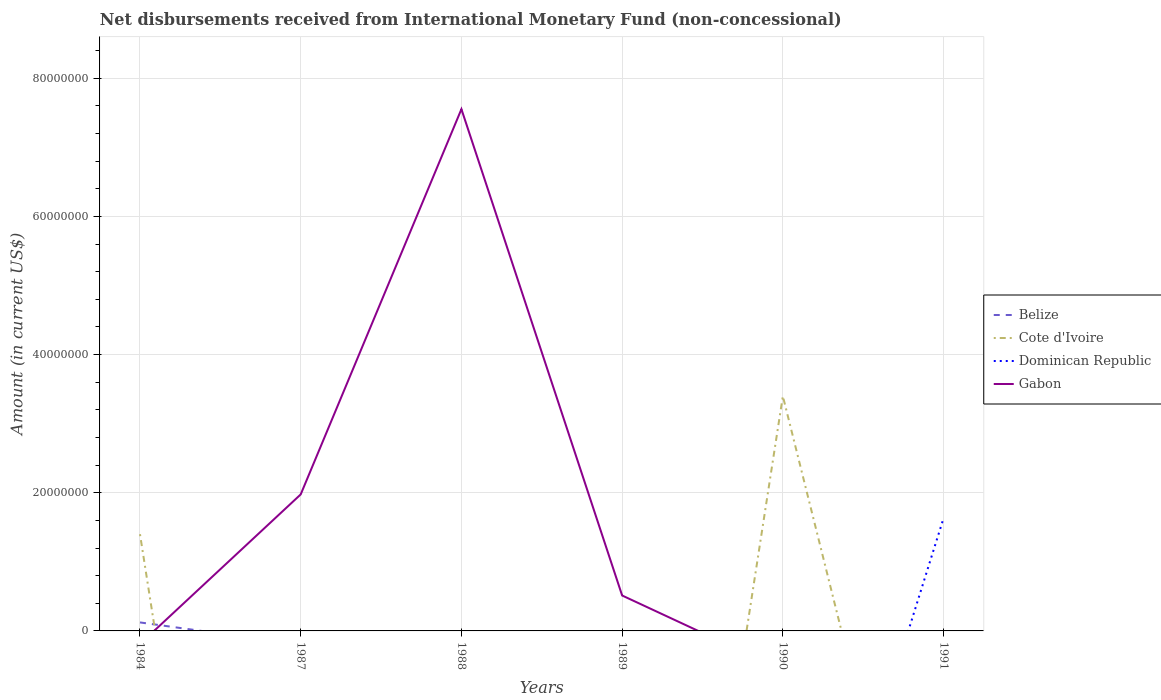Across all years, what is the maximum amount of disbursements received from International Monetary Fund in Cote d'Ivoire?
Your answer should be very brief. 0. What is the total amount of disbursements received from International Monetary Fund in Gabon in the graph?
Make the answer very short. 7.04e+07. What is the difference between the highest and the second highest amount of disbursements received from International Monetary Fund in Belize?
Your answer should be compact. 1.23e+06. How many lines are there?
Your answer should be compact. 4. How many years are there in the graph?
Offer a terse response. 6. Are the values on the major ticks of Y-axis written in scientific E-notation?
Give a very brief answer. No. Where does the legend appear in the graph?
Your answer should be very brief. Center right. How many legend labels are there?
Offer a very short reply. 4. How are the legend labels stacked?
Provide a succinct answer. Vertical. What is the title of the graph?
Ensure brevity in your answer.  Net disbursements received from International Monetary Fund (non-concessional). What is the label or title of the X-axis?
Give a very brief answer. Years. What is the label or title of the Y-axis?
Offer a terse response. Amount (in current US$). What is the Amount (in current US$) of Belize in 1984?
Offer a very short reply. 1.23e+06. What is the Amount (in current US$) of Cote d'Ivoire in 1984?
Your answer should be compact. 1.40e+07. What is the Amount (in current US$) of Dominican Republic in 1987?
Ensure brevity in your answer.  0. What is the Amount (in current US$) of Gabon in 1987?
Give a very brief answer. 1.98e+07. What is the Amount (in current US$) of Belize in 1988?
Offer a very short reply. 0. What is the Amount (in current US$) of Cote d'Ivoire in 1988?
Your response must be concise. 0. What is the Amount (in current US$) in Dominican Republic in 1988?
Your answer should be compact. 0. What is the Amount (in current US$) of Gabon in 1988?
Provide a succinct answer. 7.55e+07. What is the Amount (in current US$) in Belize in 1989?
Your answer should be very brief. 0. What is the Amount (in current US$) in Cote d'Ivoire in 1989?
Provide a short and direct response. 0. What is the Amount (in current US$) in Dominican Republic in 1989?
Your answer should be compact. 0. What is the Amount (in current US$) of Gabon in 1989?
Your answer should be compact. 5.13e+06. What is the Amount (in current US$) of Belize in 1990?
Keep it short and to the point. 0. What is the Amount (in current US$) in Cote d'Ivoire in 1990?
Your response must be concise. 3.40e+07. What is the Amount (in current US$) in Gabon in 1990?
Your answer should be compact. 0. What is the Amount (in current US$) in Belize in 1991?
Offer a terse response. 0. What is the Amount (in current US$) of Dominican Republic in 1991?
Offer a terse response. 1.63e+07. What is the Amount (in current US$) in Gabon in 1991?
Provide a short and direct response. 0. Across all years, what is the maximum Amount (in current US$) in Belize?
Keep it short and to the point. 1.23e+06. Across all years, what is the maximum Amount (in current US$) of Cote d'Ivoire?
Keep it short and to the point. 3.40e+07. Across all years, what is the maximum Amount (in current US$) in Dominican Republic?
Provide a short and direct response. 1.63e+07. Across all years, what is the maximum Amount (in current US$) in Gabon?
Keep it short and to the point. 7.55e+07. What is the total Amount (in current US$) of Belize in the graph?
Provide a short and direct response. 1.23e+06. What is the total Amount (in current US$) of Cote d'Ivoire in the graph?
Your answer should be very brief. 4.80e+07. What is the total Amount (in current US$) of Dominican Republic in the graph?
Ensure brevity in your answer.  1.63e+07. What is the total Amount (in current US$) of Gabon in the graph?
Your answer should be very brief. 1.00e+08. What is the difference between the Amount (in current US$) of Cote d'Ivoire in 1984 and that in 1990?
Offer a very short reply. -2.00e+07. What is the difference between the Amount (in current US$) of Gabon in 1987 and that in 1988?
Ensure brevity in your answer.  -5.58e+07. What is the difference between the Amount (in current US$) of Gabon in 1987 and that in 1989?
Provide a succinct answer. 1.46e+07. What is the difference between the Amount (in current US$) in Gabon in 1988 and that in 1989?
Your answer should be compact. 7.04e+07. What is the difference between the Amount (in current US$) of Belize in 1984 and the Amount (in current US$) of Gabon in 1987?
Keep it short and to the point. -1.85e+07. What is the difference between the Amount (in current US$) of Cote d'Ivoire in 1984 and the Amount (in current US$) of Gabon in 1987?
Provide a short and direct response. -5.76e+06. What is the difference between the Amount (in current US$) in Belize in 1984 and the Amount (in current US$) in Gabon in 1988?
Offer a terse response. -7.43e+07. What is the difference between the Amount (in current US$) of Cote d'Ivoire in 1984 and the Amount (in current US$) of Gabon in 1988?
Your answer should be very brief. -6.15e+07. What is the difference between the Amount (in current US$) of Belize in 1984 and the Amount (in current US$) of Gabon in 1989?
Offer a very short reply. -3.90e+06. What is the difference between the Amount (in current US$) in Cote d'Ivoire in 1984 and the Amount (in current US$) in Gabon in 1989?
Your answer should be compact. 8.87e+06. What is the difference between the Amount (in current US$) of Belize in 1984 and the Amount (in current US$) of Cote d'Ivoire in 1990?
Your answer should be very brief. -3.28e+07. What is the difference between the Amount (in current US$) in Belize in 1984 and the Amount (in current US$) in Dominican Republic in 1991?
Provide a succinct answer. -1.51e+07. What is the difference between the Amount (in current US$) of Cote d'Ivoire in 1984 and the Amount (in current US$) of Dominican Republic in 1991?
Provide a succinct answer. -2.33e+06. What is the difference between the Amount (in current US$) of Cote d'Ivoire in 1990 and the Amount (in current US$) of Dominican Republic in 1991?
Ensure brevity in your answer.  1.77e+07. What is the average Amount (in current US$) in Belize per year?
Keep it short and to the point. 2.05e+05. What is the average Amount (in current US$) of Cote d'Ivoire per year?
Offer a very short reply. 8.00e+06. What is the average Amount (in current US$) of Dominican Republic per year?
Make the answer very short. 2.72e+06. What is the average Amount (in current US$) of Gabon per year?
Offer a very short reply. 1.67e+07. In the year 1984, what is the difference between the Amount (in current US$) in Belize and Amount (in current US$) in Cote d'Ivoire?
Provide a short and direct response. -1.28e+07. What is the ratio of the Amount (in current US$) of Cote d'Ivoire in 1984 to that in 1990?
Provide a succinct answer. 0.41. What is the ratio of the Amount (in current US$) of Gabon in 1987 to that in 1988?
Offer a terse response. 0.26. What is the ratio of the Amount (in current US$) of Gabon in 1987 to that in 1989?
Ensure brevity in your answer.  3.85. What is the ratio of the Amount (in current US$) in Gabon in 1988 to that in 1989?
Keep it short and to the point. 14.73. What is the difference between the highest and the second highest Amount (in current US$) of Gabon?
Ensure brevity in your answer.  5.58e+07. What is the difference between the highest and the lowest Amount (in current US$) of Belize?
Your response must be concise. 1.23e+06. What is the difference between the highest and the lowest Amount (in current US$) in Cote d'Ivoire?
Your answer should be very brief. 3.40e+07. What is the difference between the highest and the lowest Amount (in current US$) in Dominican Republic?
Ensure brevity in your answer.  1.63e+07. What is the difference between the highest and the lowest Amount (in current US$) in Gabon?
Ensure brevity in your answer.  7.55e+07. 